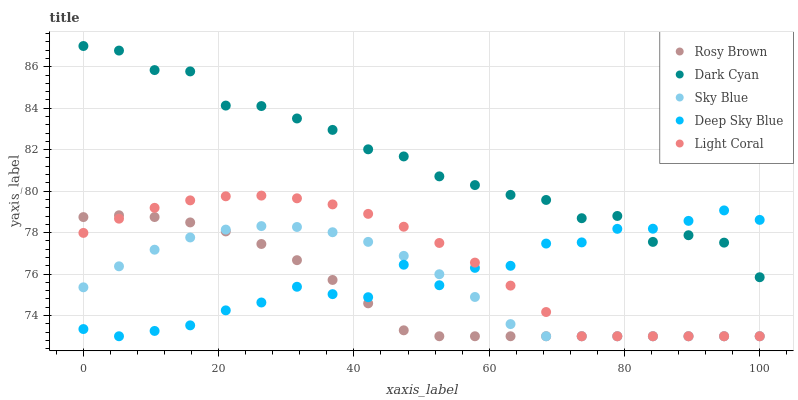Does Rosy Brown have the minimum area under the curve?
Answer yes or no. Yes. Does Dark Cyan have the maximum area under the curve?
Answer yes or no. Yes. Does Sky Blue have the minimum area under the curve?
Answer yes or no. No. Does Sky Blue have the maximum area under the curve?
Answer yes or no. No. Is Rosy Brown the smoothest?
Answer yes or no. Yes. Is Deep Sky Blue the roughest?
Answer yes or no. Yes. Is Sky Blue the smoothest?
Answer yes or no. No. Is Sky Blue the roughest?
Answer yes or no. No. Does Sky Blue have the lowest value?
Answer yes or no. Yes. Does Dark Cyan have the highest value?
Answer yes or no. Yes. Does Light Coral have the highest value?
Answer yes or no. No. Is Sky Blue less than Dark Cyan?
Answer yes or no. Yes. Is Dark Cyan greater than Sky Blue?
Answer yes or no. Yes. Does Light Coral intersect Rosy Brown?
Answer yes or no. Yes. Is Light Coral less than Rosy Brown?
Answer yes or no. No. Is Light Coral greater than Rosy Brown?
Answer yes or no. No. Does Sky Blue intersect Dark Cyan?
Answer yes or no. No. 